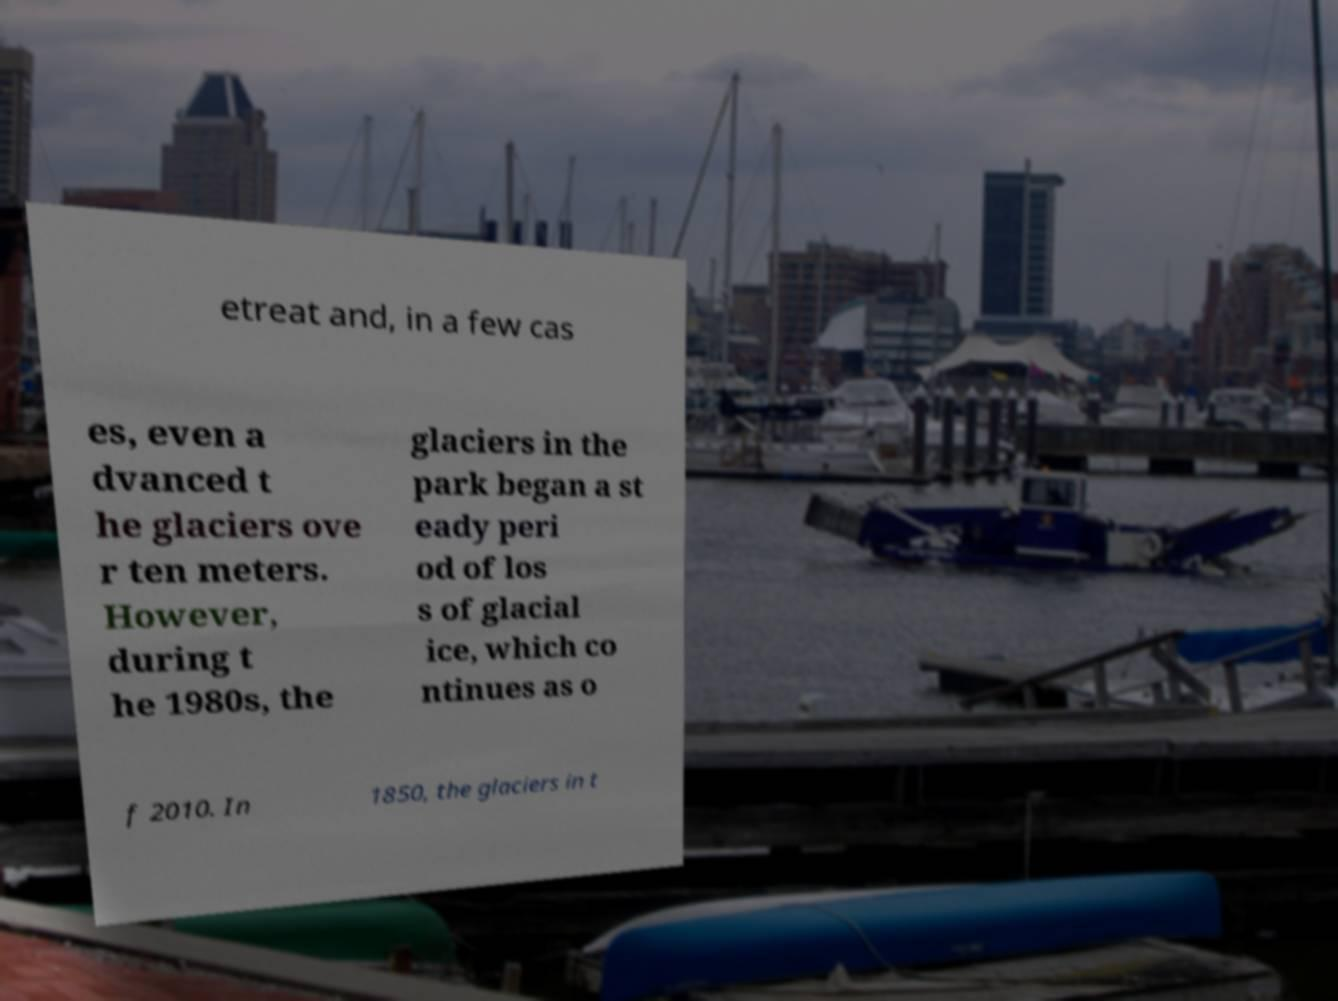I need the written content from this picture converted into text. Can you do that? etreat and, in a few cas es, even a dvanced t he glaciers ove r ten meters. However, during t he 1980s, the glaciers in the park began a st eady peri od of los s of glacial ice, which co ntinues as o f 2010. In 1850, the glaciers in t 